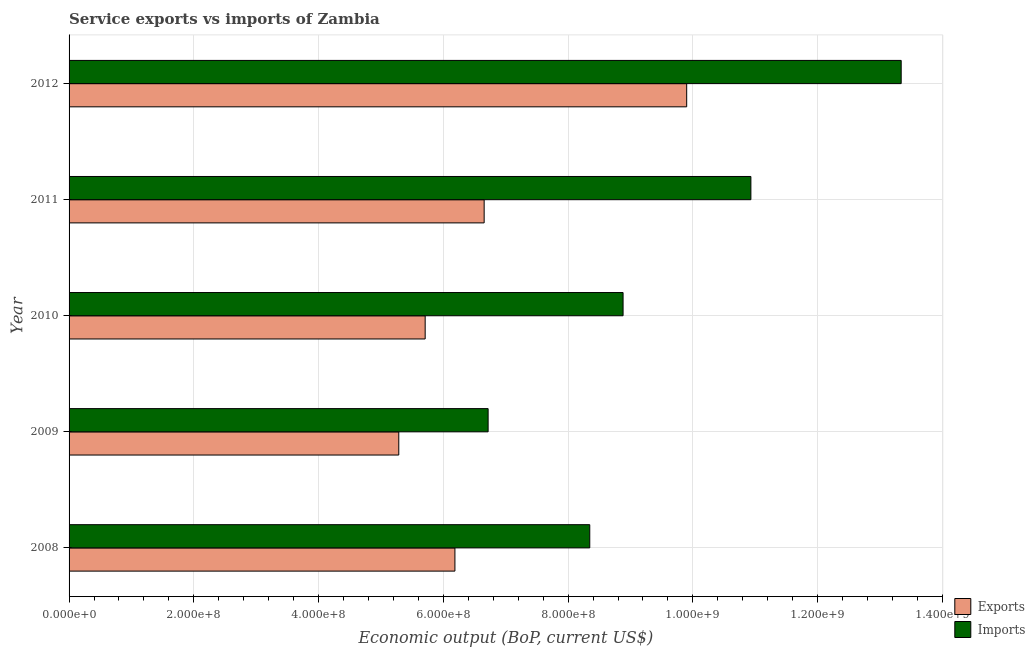How many different coloured bars are there?
Your answer should be compact. 2. How many groups of bars are there?
Keep it short and to the point. 5. How many bars are there on the 4th tick from the bottom?
Keep it short and to the point. 2. What is the amount of service exports in 2010?
Offer a very short reply. 5.71e+08. Across all years, what is the maximum amount of service exports?
Provide a short and direct response. 9.90e+08. Across all years, what is the minimum amount of service exports?
Make the answer very short. 5.29e+08. In which year was the amount of service imports maximum?
Offer a very short reply. 2012. What is the total amount of service exports in the graph?
Your response must be concise. 3.37e+09. What is the difference between the amount of service exports in 2010 and that in 2012?
Keep it short and to the point. -4.19e+08. What is the difference between the amount of service imports in 2012 and the amount of service exports in 2010?
Keep it short and to the point. 7.63e+08. What is the average amount of service imports per year?
Offer a terse response. 9.64e+08. In the year 2009, what is the difference between the amount of service imports and amount of service exports?
Offer a very short reply. 1.43e+08. In how many years, is the amount of service imports greater than 560000000 US$?
Provide a succinct answer. 5. What is the ratio of the amount of service exports in 2009 to that in 2011?
Provide a short and direct response. 0.79. Is the amount of service imports in 2008 less than that in 2010?
Make the answer very short. Yes. What is the difference between the highest and the second highest amount of service exports?
Provide a succinct answer. 3.25e+08. What is the difference between the highest and the lowest amount of service imports?
Your answer should be very brief. 6.62e+08. What does the 1st bar from the top in 2008 represents?
Your answer should be very brief. Imports. What does the 1st bar from the bottom in 2012 represents?
Keep it short and to the point. Exports. How many bars are there?
Ensure brevity in your answer.  10. How many years are there in the graph?
Provide a succinct answer. 5. What is the difference between two consecutive major ticks on the X-axis?
Your answer should be compact. 2.00e+08. Are the values on the major ticks of X-axis written in scientific E-notation?
Provide a short and direct response. Yes. Does the graph contain grids?
Ensure brevity in your answer.  Yes. How many legend labels are there?
Your response must be concise. 2. How are the legend labels stacked?
Make the answer very short. Vertical. What is the title of the graph?
Make the answer very short. Service exports vs imports of Zambia. What is the label or title of the X-axis?
Provide a short and direct response. Economic output (BoP, current US$). What is the Economic output (BoP, current US$) of Exports in 2008?
Give a very brief answer. 6.19e+08. What is the Economic output (BoP, current US$) of Imports in 2008?
Give a very brief answer. 8.35e+08. What is the Economic output (BoP, current US$) in Exports in 2009?
Offer a terse response. 5.29e+08. What is the Economic output (BoP, current US$) of Imports in 2009?
Your answer should be very brief. 6.72e+08. What is the Economic output (BoP, current US$) in Exports in 2010?
Provide a short and direct response. 5.71e+08. What is the Economic output (BoP, current US$) of Imports in 2010?
Your response must be concise. 8.88e+08. What is the Economic output (BoP, current US$) of Exports in 2011?
Provide a succinct answer. 6.65e+08. What is the Economic output (BoP, current US$) of Imports in 2011?
Give a very brief answer. 1.09e+09. What is the Economic output (BoP, current US$) in Exports in 2012?
Provide a short and direct response. 9.90e+08. What is the Economic output (BoP, current US$) of Imports in 2012?
Your answer should be compact. 1.33e+09. Across all years, what is the maximum Economic output (BoP, current US$) in Exports?
Your response must be concise. 9.90e+08. Across all years, what is the maximum Economic output (BoP, current US$) in Imports?
Offer a very short reply. 1.33e+09. Across all years, what is the minimum Economic output (BoP, current US$) of Exports?
Your answer should be compact. 5.29e+08. Across all years, what is the minimum Economic output (BoP, current US$) of Imports?
Keep it short and to the point. 6.72e+08. What is the total Economic output (BoP, current US$) of Exports in the graph?
Keep it short and to the point. 3.37e+09. What is the total Economic output (BoP, current US$) in Imports in the graph?
Your response must be concise. 4.82e+09. What is the difference between the Economic output (BoP, current US$) of Exports in 2008 and that in 2009?
Provide a short and direct response. 9.00e+07. What is the difference between the Economic output (BoP, current US$) in Imports in 2008 and that in 2009?
Provide a succinct answer. 1.63e+08. What is the difference between the Economic output (BoP, current US$) of Exports in 2008 and that in 2010?
Offer a terse response. 4.77e+07. What is the difference between the Economic output (BoP, current US$) of Imports in 2008 and that in 2010?
Provide a short and direct response. -5.34e+07. What is the difference between the Economic output (BoP, current US$) of Exports in 2008 and that in 2011?
Provide a short and direct response. -4.69e+07. What is the difference between the Economic output (BoP, current US$) of Imports in 2008 and that in 2011?
Your response must be concise. -2.58e+08. What is the difference between the Economic output (BoP, current US$) in Exports in 2008 and that in 2012?
Ensure brevity in your answer.  -3.72e+08. What is the difference between the Economic output (BoP, current US$) in Imports in 2008 and that in 2012?
Your response must be concise. -4.99e+08. What is the difference between the Economic output (BoP, current US$) in Exports in 2009 and that in 2010?
Your answer should be very brief. -4.23e+07. What is the difference between the Economic output (BoP, current US$) of Imports in 2009 and that in 2010?
Your answer should be very brief. -2.16e+08. What is the difference between the Economic output (BoP, current US$) in Exports in 2009 and that in 2011?
Offer a very short reply. -1.37e+08. What is the difference between the Economic output (BoP, current US$) of Imports in 2009 and that in 2011?
Ensure brevity in your answer.  -4.21e+08. What is the difference between the Economic output (BoP, current US$) of Exports in 2009 and that in 2012?
Your answer should be compact. -4.62e+08. What is the difference between the Economic output (BoP, current US$) of Imports in 2009 and that in 2012?
Make the answer very short. -6.62e+08. What is the difference between the Economic output (BoP, current US$) in Exports in 2010 and that in 2011?
Your response must be concise. -9.46e+07. What is the difference between the Economic output (BoP, current US$) of Imports in 2010 and that in 2011?
Your answer should be compact. -2.05e+08. What is the difference between the Economic output (BoP, current US$) of Exports in 2010 and that in 2012?
Give a very brief answer. -4.19e+08. What is the difference between the Economic output (BoP, current US$) of Imports in 2010 and that in 2012?
Make the answer very short. -4.46e+08. What is the difference between the Economic output (BoP, current US$) of Exports in 2011 and that in 2012?
Ensure brevity in your answer.  -3.25e+08. What is the difference between the Economic output (BoP, current US$) in Imports in 2011 and that in 2012?
Your answer should be compact. -2.41e+08. What is the difference between the Economic output (BoP, current US$) in Exports in 2008 and the Economic output (BoP, current US$) in Imports in 2009?
Give a very brief answer. -5.32e+07. What is the difference between the Economic output (BoP, current US$) in Exports in 2008 and the Economic output (BoP, current US$) in Imports in 2010?
Your answer should be compact. -2.70e+08. What is the difference between the Economic output (BoP, current US$) of Exports in 2008 and the Economic output (BoP, current US$) of Imports in 2011?
Keep it short and to the point. -4.74e+08. What is the difference between the Economic output (BoP, current US$) in Exports in 2008 and the Economic output (BoP, current US$) in Imports in 2012?
Your answer should be very brief. -7.15e+08. What is the difference between the Economic output (BoP, current US$) of Exports in 2009 and the Economic output (BoP, current US$) of Imports in 2010?
Keep it short and to the point. -3.60e+08. What is the difference between the Economic output (BoP, current US$) of Exports in 2009 and the Economic output (BoP, current US$) of Imports in 2011?
Your answer should be very brief. -5.64e+08. What is the difference between the Economic output (BoP, current US$) in Exports in 2009 and the Economic output (BoP, current US$) in Imports in 2012?
Offer a very short reply. -8.05e+08. What is the difference between the Economic output (BoP, current US$) of Exports in 2010 and the Economic output (BoP, current US$) of Imports in 2011?
Make the answer very short. -5.22e+08. What is the difference between the Economic output (BoP, current US$) of Exports in 2010 and the Economic output (BoP, current US$) of Imports in 2012?
Offer a terse response. -7.63e+08. What is the difference between the Economic output (BoP, current US$) of Exports in 2011 and the Economic output (BoP, current US$) of Imports in 2012?
Offer a terse response. -6.69e+08. What is the average Economic output (BoP, current US$) in Exports per year?
Offer a terse response. 6.75e+08. What is the average Economic output (BoP, current US$) in Imports per year?
Your answer should be very brief. 9.64e+08. In the year 2008, what is the difference between the Economic output (BoP, current US$) in Exports and Economic output (BoP, current US$) in Imports?
Provide a short and direct response. -2.16e+08. In the year 2009, what is the difference between the Economic output (BoP, current US$) of Exports and Economic output (BoP, current US$) of Imports?
Your answer should be very brief. -1.43e+08. In the year 2010, what is the difference between the Economic output (BoP, current US$) in Exports and Economic output (BoP, current US$) in Imports?
Provide a succinct answer. -3.17e+08. In the year 2011, what is the difference between the Economic output (BoP, current US$) of Exports and Economic output (BoP, current US$) of Imports?
Your answer should be compact. -4.28e+08. In the year 2012, what is the difference between the Economic output (BoP, current US$) in Exports and Economic output (BoP, current US$) in Imports?
Your response must be concise. -3.44e+08. What is the ratio of the Economic output (BoP, current US$) in Exports in 2008 to that in 2009?
Your answer should be compact. 1.17. What is the ratio of the Economic output (BoP, current US$) in Imports in 2008 to that in 2009?
Provide a succinct answer. 1.24. What is the ratio of the Economic output (BoP, current US$) of Exports in 2008 to that in 2010?
Your response must be concise. 1.08. What is the ratio of the Economic output (BoP, current US$) of Imports in 2008 to that in 2010?
Make the answer very short. 0.94. What is the ratio of the Economic output (BoP, current US$) in Exports in 2008 to that in 2011?
Give a very brief answer. 0.93. What is the ratio of the Economic output (BoP, current US$) in Imports in 2008 to that in 2011?
Your answer should be compact. 0.76. What is the ratio of the Economic output (BoP, current US$) in Exports in 2008 to that in 2012?
Provide a succinct answer. 0.62. What is the ratio of the Economic output (BoP, current US$) in Imports in 2008 to that in 2012?
Your response must be concise. 0.63. What is the ratio of the Economic output (BoP, current US$) in Exports in 2009 to that in 2010?
Your answer should be compact. 0.93. What is the ratio of the Economic output (BoP, current US$) of Imports in 2009 to that in 2010?
Your answer should be compact. 0.76. What is the ratio of the Economic output (BoP, current US$) in Exports in 2009 to that in 2011?
Make the answer very short. 0.79. What is the ratio of the Economic output (BoP, current US$) in Imports in 2009 to that in 2011?
Make the answer very short. 0.61. What is the ratio of the Economic output (BoP, current US$) in Exports in 2009 to that in 2012?
Ensure brevity in your answer.  0.53. What is the ratio of the Economic output (BoP, current US$) of Imports in 2009 to that in 2012?
Offer a very short reply. 0.5. What is the ratio of the Economic output (BoP, current US$) of Exports in 2010 to that in 2011?
Provide a short and direct response. 0.86. What is the ratio of the Economic output (BoP, current US$) in Imports in 2010 to that in 2011?
Keep it short and to the point. 0.81. What is the ratio of the Economic output (BoP, current US$) of Exports in 2010 to that in 2012?
Your answer should be very brief. 0.58. What is the ratio of the Economic output (BoP, current US$) in Imports in 2010 to that in 2012?
Provide a short and direct response. 0.67. What is the ratio of the Economic output (BoP, current US$) in Exports in 2011 to that in 2012?
Your answer should be very brief. 0.67. What is the ratio of the Economic output (BoP, current US$) of Imports in 2011 to that in 2012?
Provide a succinct answer. 0.82. What is the difference between the highest and the second highest Economic output (BoP, current US$) of Exports?
Provide a succinct answer. 3.25e+08. What is the difference between the highest and the second highest Economic output (BoP, current US$) of Imports?
Your answer should be compact. 2.41e+08. What is the difference between the highest and the lowest Economic output (BoP, current US$) of Exports?
Provide a succinct answer. 4.62e+08. What is the difference between the highest and the lowest Economic output (BoP, current US$) in Imports?
Provide a succinct answer. 6.62e+08. 